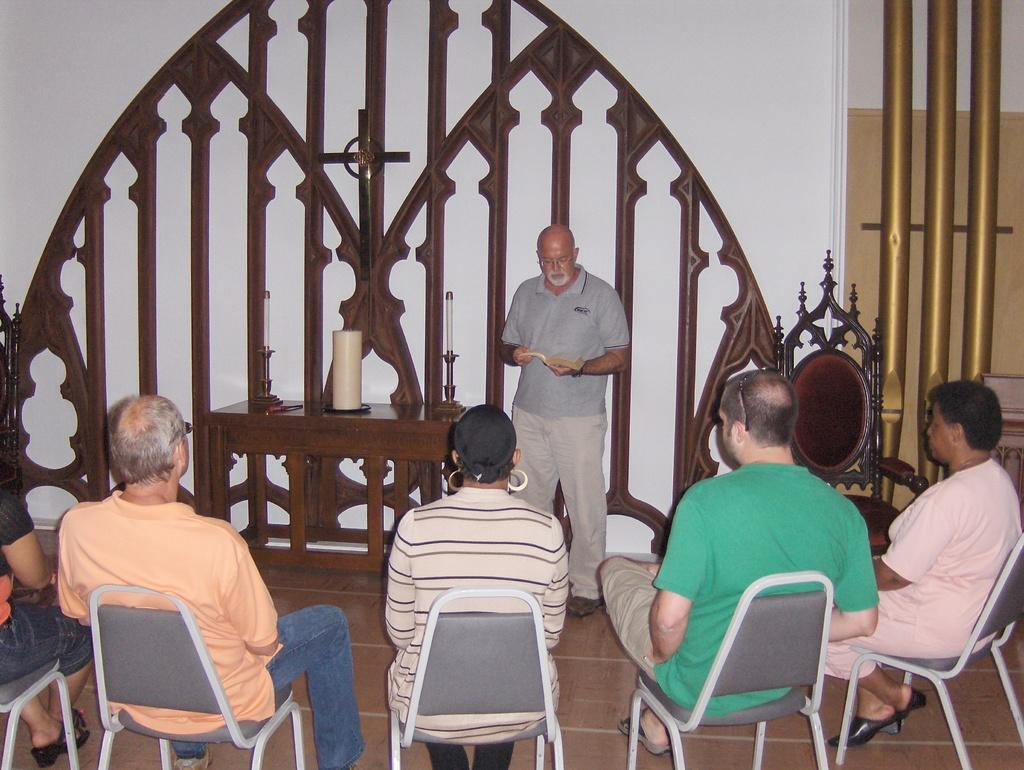What is the color of the wall in the image? The wall in the image is white. What are the people in the image doing? The people in the image are sitting on chairs. What piece of furniture is present in the image? There is a table in the image. What objects can be seen on the table? Candles are present on the table. What is the price of the tree visible in the image? There is no tree present in the image, so it is not possible to determine its price. 